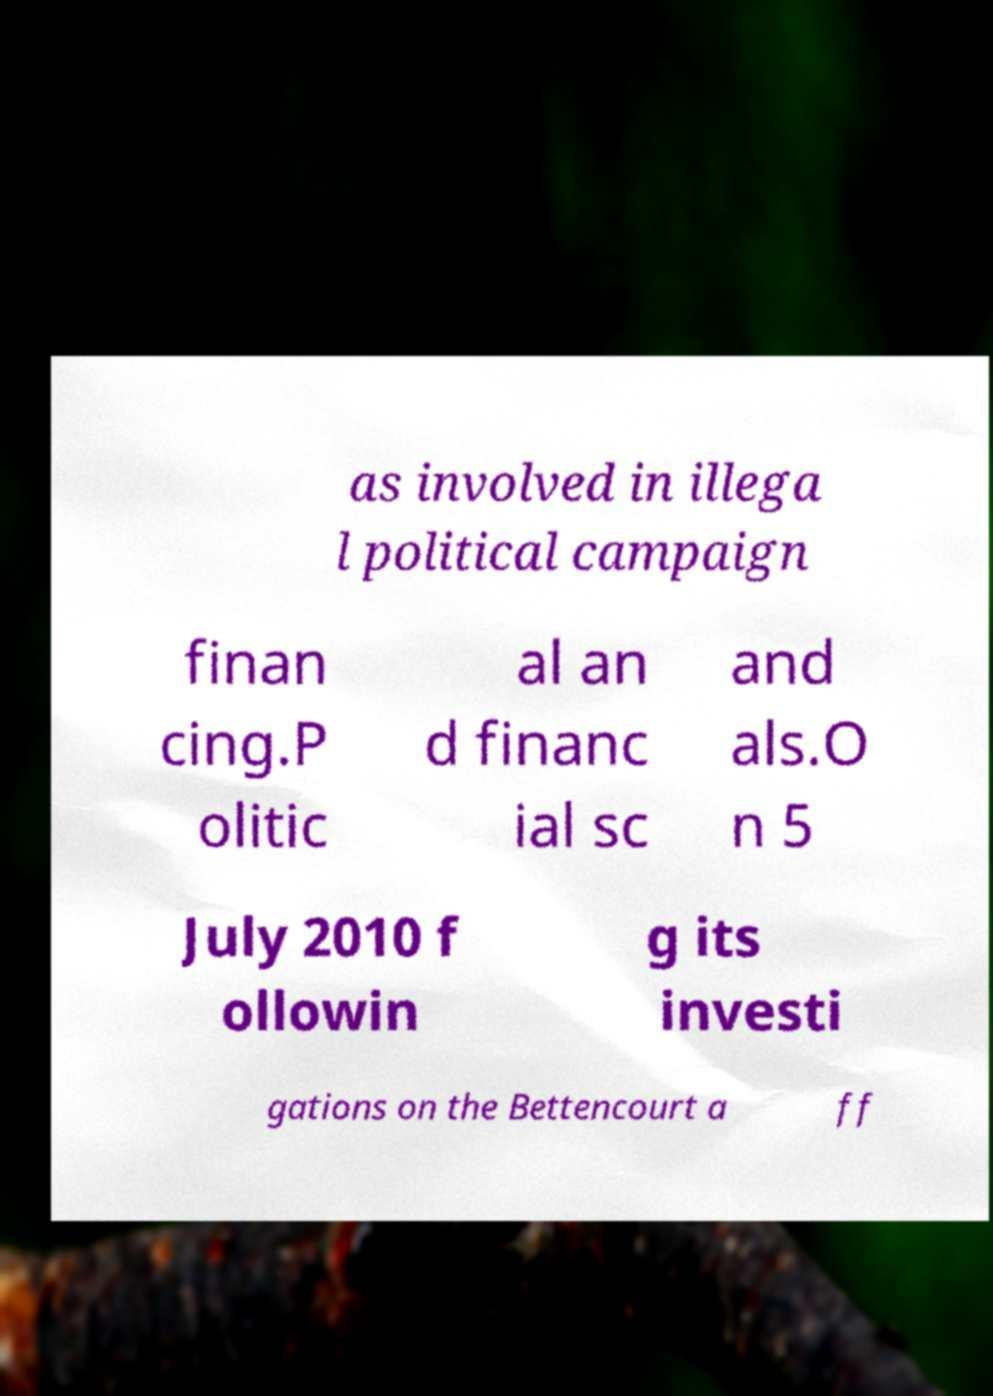For documentation purposes, I need the text within this image transcribed. Could you provide that? as involved in illega l political campaign finan cing.P olitic al an d financ ial sc and als.O n 5 July 2010 f ollowin g its investi gations on the Bettencourt a ff 